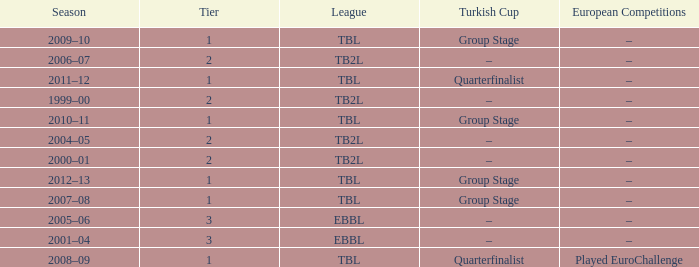Tier of 2, and a Season of 2004–05 is what European competitions? –. 